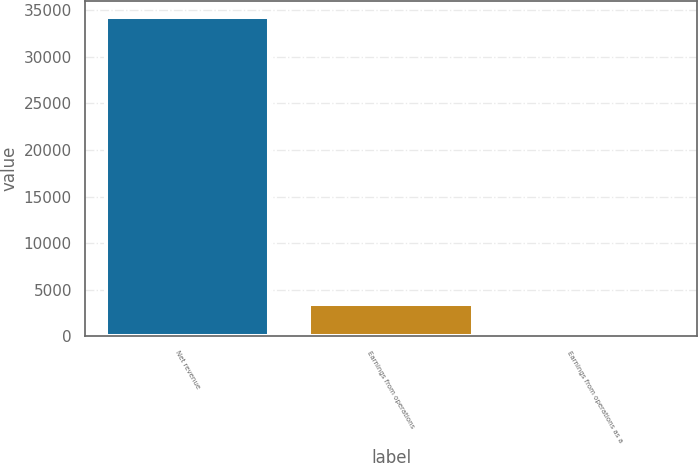<chart> <loc_0><loc_0><loc_500><loc_500><bar_chart><fcel>Net revenue<fcel>Earnings from operations<fcel>Earnings from operations as a<nl><fcel>34303<fcel>3433.63<fcel>3.7<nl></chart> 